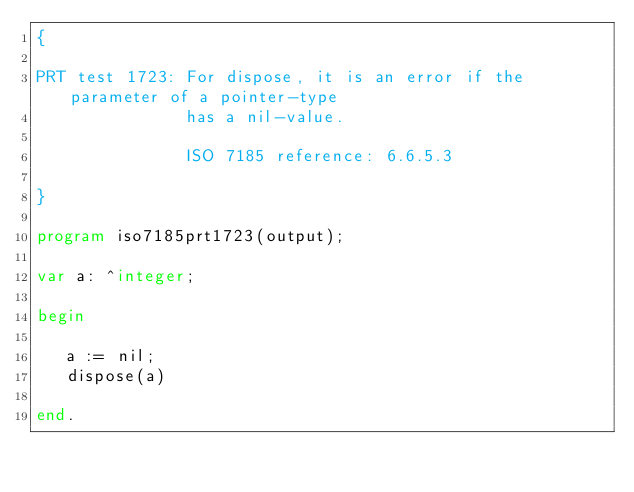Convert code to text. <code><loc_0><loc_0><loc_500><loc_500><_Pascal_>{

PRT test 1723: For dispose, it is an error if the parameter of a pointer-type
               has a nil-value.

               ISO 7185 reference: 6.6.5.3

}

program iso7185prt1723(output);

var a: ^integer;

begin

   a := nil;
   dispose(a)

end.
</code> 